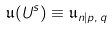Convert formula to latex. <formula><loc_0><loc_0><loc_500><loc_500>\mathfrak { u } ( U ^ { s } ) \equiv \mathfrak { u } _ { n | p , \, q }</formula> 